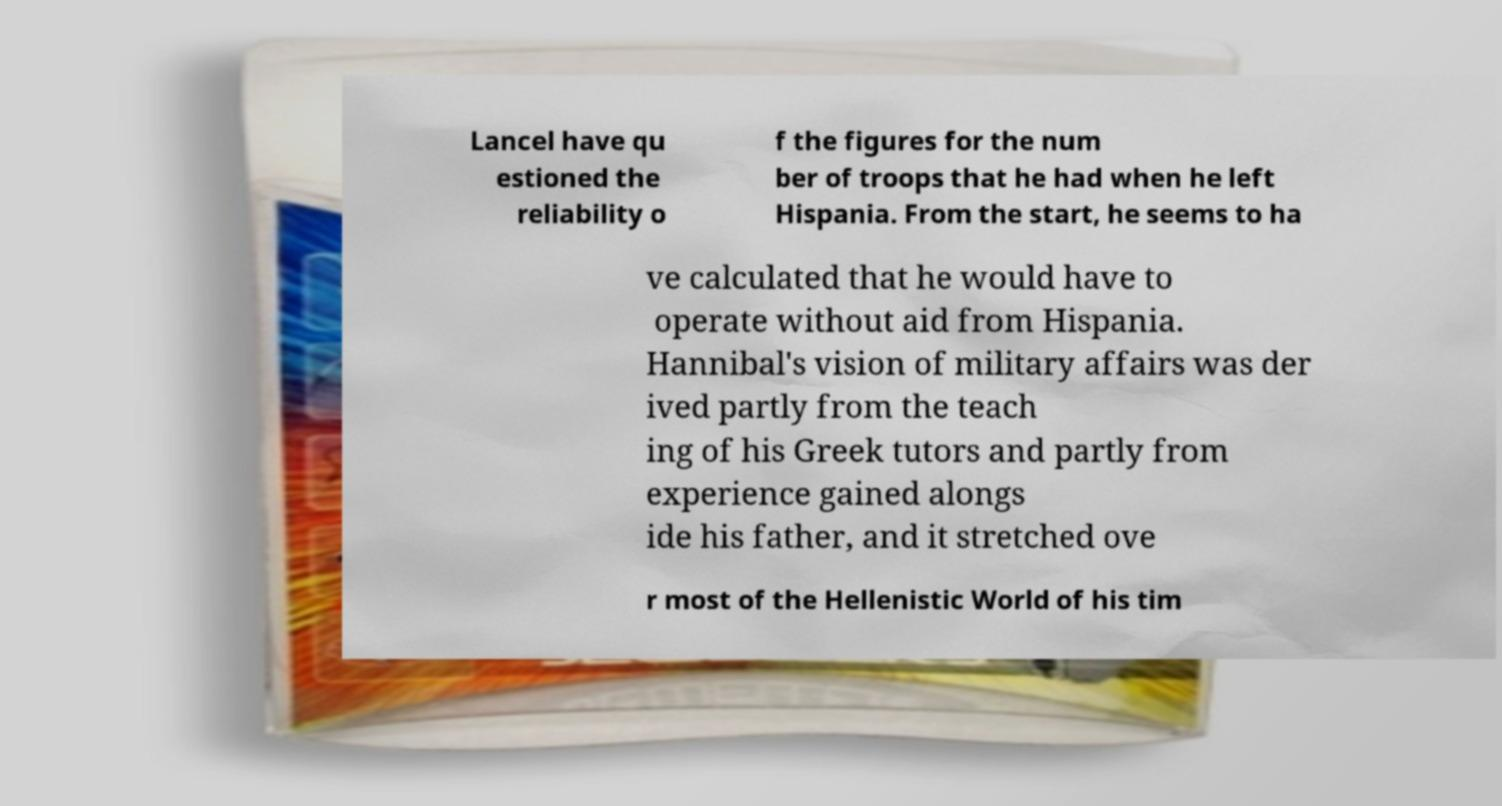For documentation purposes, I need the text within this image transcribed. Could you provide that? Lancel have qu estioned the reliability o f the figures for the num ber of troops that he had when he left Hispania. From the start, he seems to ha ve calculated that he would have to operate without aid from Hispania. Hannibal's vision of military affairs was der ived partly from the teach ing of his Greek tutors and partly from experience gained alongs ide his father, and it stretched ove r most of the Hellenistic World of his tim 